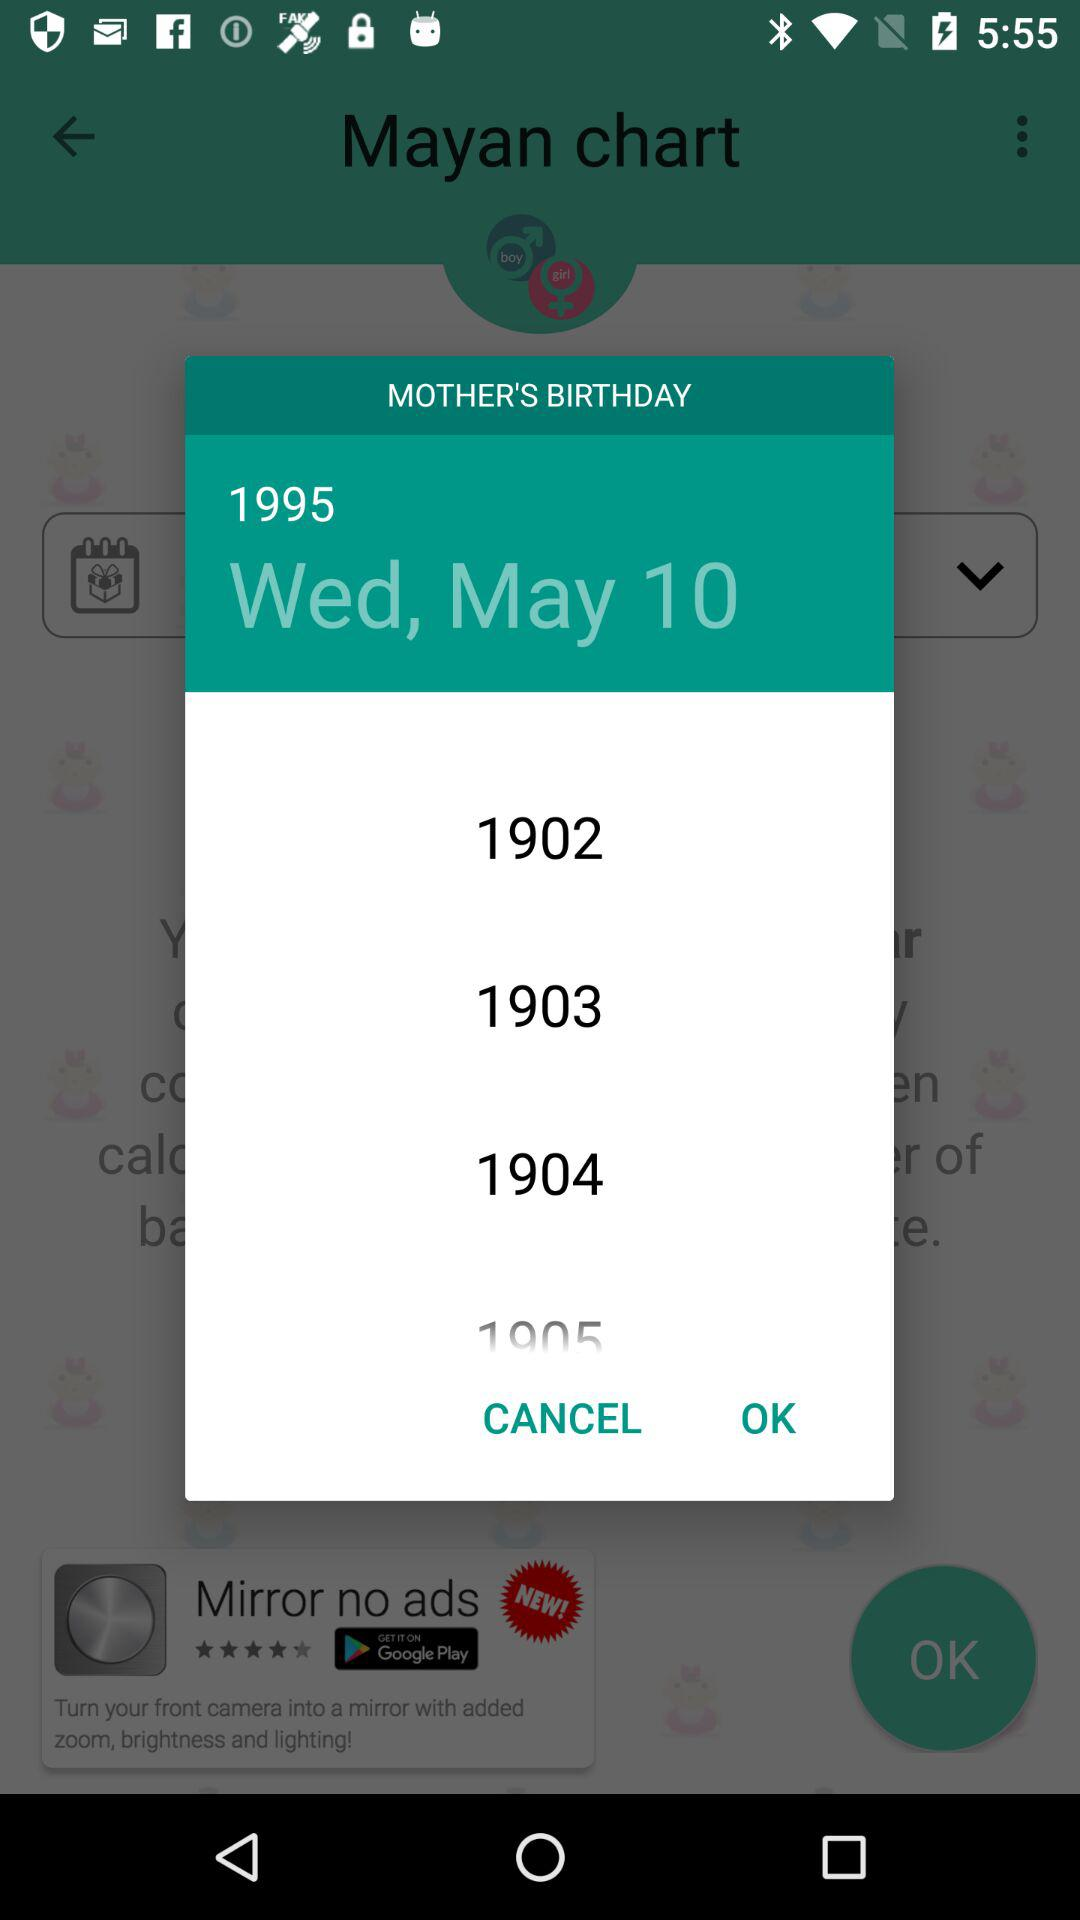What is the mother's birthday date? The mother's birthday date is Wednesday, May 10, 1995. 